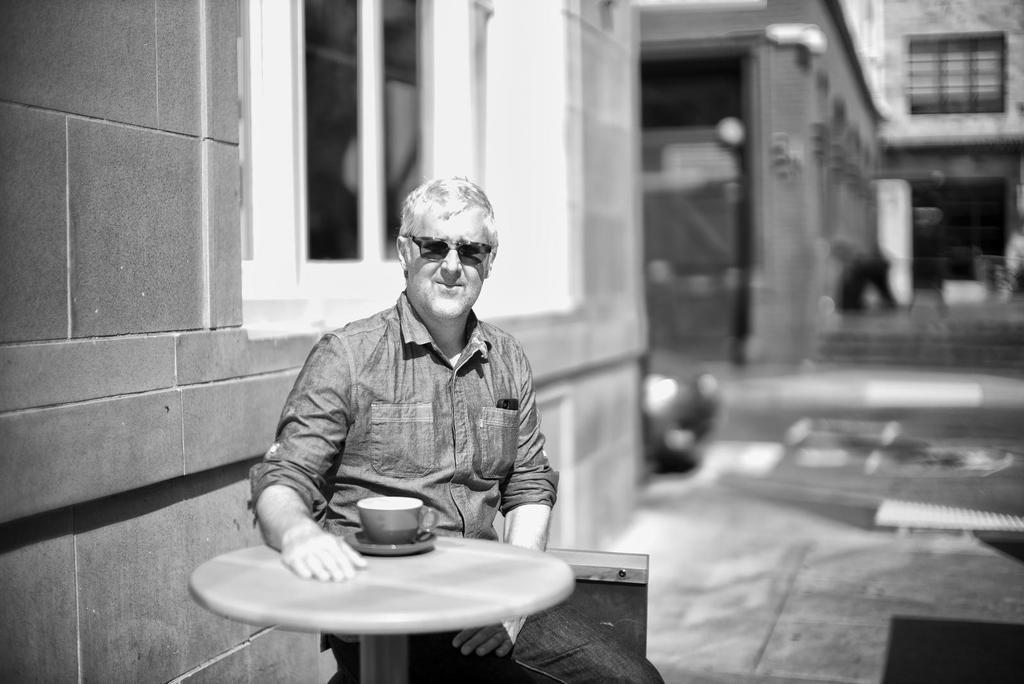What is the person in the image doing? The person is sitting in the image. Where is the person sitting in relation to the table? The person is sitting in front of a table. What object can be seen on the table? There is a cup on the table. What type of noise can be heard coming from the cows in the image? There are no cows present in the image, so it's not possible to determine what, if any, noise might be heard. 